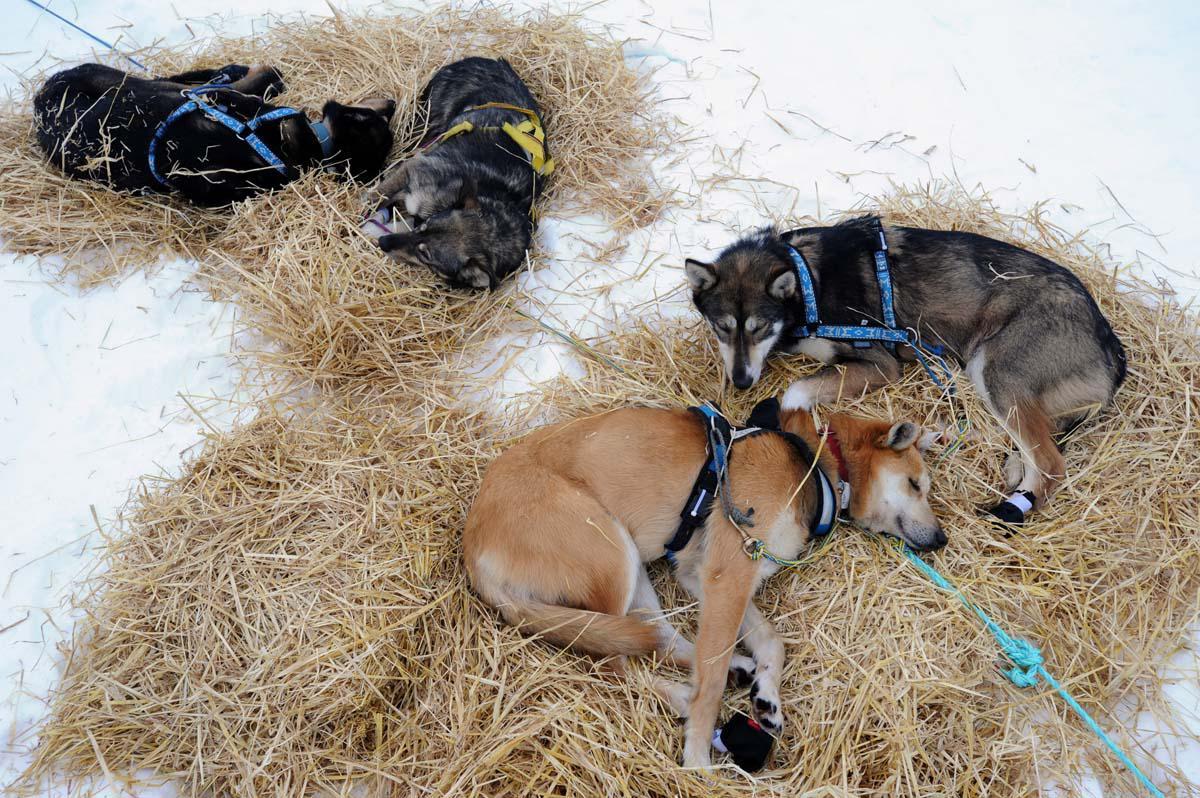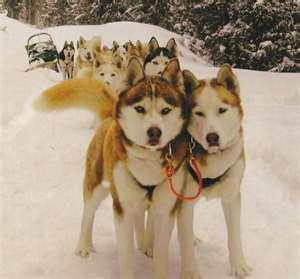The first image is the image on the left, the second image is the image on the right. Given the left and right images, does the statement "In only one of the two images are the dogs awake." hold true? Answer yes or no. Yes. The first image is the image on the left, the second image is the image on the right. Analyze the images presented: Is the assertion "One image shows a team of dogs hitched to a sled, and the other image shows a brown, non-husky dog posed with a sled but not hitched to pull it." valid? Answer yes or no. No. 